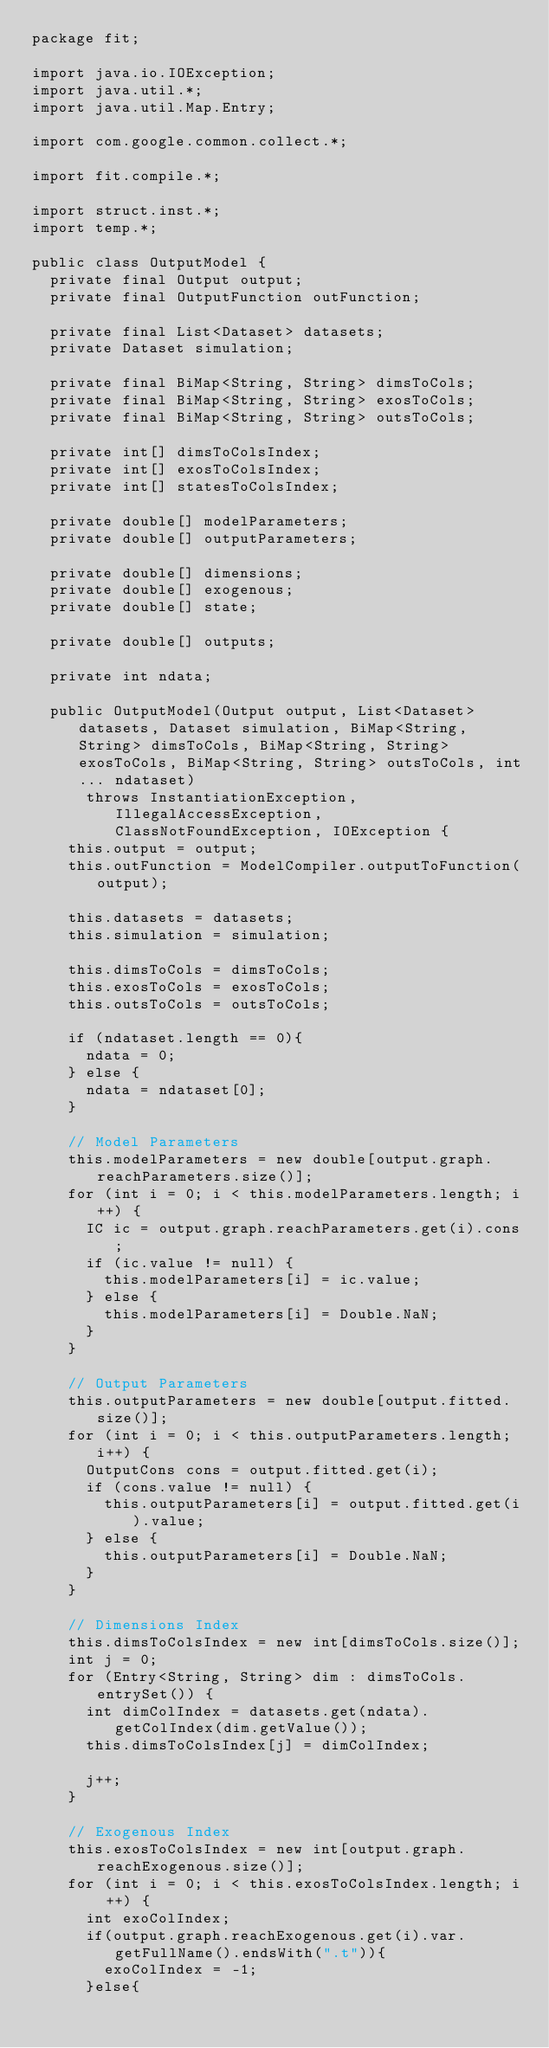Convert code to text. <code><loc_0><loc_0><loc_500><loc_500><_Java_>package fit;

import java.io.IOException;
import java.util.*;
import java.util.Map.Entry;

import com.google.common.collect.*;

import fit.compile.*;

import struct.inst.*;
import temp.*;

public class OutputModel {
	private final Output output;
	private final OutputFunction outFunction;

	private final List<Dataset> datasets;
	private Dataset simulation;

	private final BiMap<String, String> dimsToCols;
	private final BiMap<String, String> exosToCols;
	private final BiMap<String, String> outsToCols;

	private int[] dimsToColsIndex;
	private int[] exosToColsIndex;
	private int[] statesToColsIndex;

	private double[] modelParameters;
	private double[] outputParameters;

	private double[] dimensions;
	private double[] exogenous;
	private double[] state;

	private double[] outputs;
	
	private int ndata;

	public OutputModel(Output output, List<Dataset> datasets, Dataset simulation, BiMap<String, String> dimsToCols, BiMap<String, String> exosToCols, BiMap<String, String> outsToCols, int... ndataset)
			throws InstantiationException, IllegalAccessException, ClassNotFoundException, IOException {
		this.output = output;
		this.outFunction = ModelCompiler.outputToFunction(output);

		this.datasets = datasets;
		this.simulation = simulation;

		this.dimsToCols = dimsToCols;
		this.exosToCols = exosToCols;
		this.outsToCols = outsToCols;
		
		if (ndataset.length == 0){
			ndata = 0;
		} else {
			ndata = ndataset[0];
		}

		// Model Parameters
		this.modelParameters = new double[output.graph.reachParameters.size()];
		for (int i = 0; i < this.modelParameters.length; i++) {
			IC ic = output.graph.reachParameters.get(i).cons;
			if (ic.value != null) {
				this.modelParameters[i] = ic.value;
			} else {
				this.modelParameters[i] = Double.NaN;
			}
		}

		// Output Parameters
		this.outputParameters = new double[output.fitted.size()];
		for (int i = 0; i < this.outputParameters.length; i++) {
			OutputCons cons = output.fitted.get(i);
			if (cons.value != null) {
				this.outputParameters[i] = output.fitted.get(i).value;
			} else {
				this.outputParameters[i] = Double.NaN;
			}
		}

		// Dimensions Index
		this.dimsToColsIndex = new int[dimsToCols.size()];
		int j = 0;
		for (Entry<String, String> dim : dimsToCols.entrySet()) {
			int dimColIndex = datasets.get(ndata).getColIndex(dim.getValue());
			this.dimsToColsIndex[j] = dimColIndex;

			j++;
		}

		// Exogenous Index
		this.exosToColsIndex = new int[output.graph.reachExogenous.size()];
		for (int i = 0; i < this.exosToColsIndex.length; i ++) {
			int exoColIndex;
			if(output.graph.reachExogenous.get(i).var.getFullName().endsWith(".t")){
				exoColIndex = -1;
			}else{</code> 